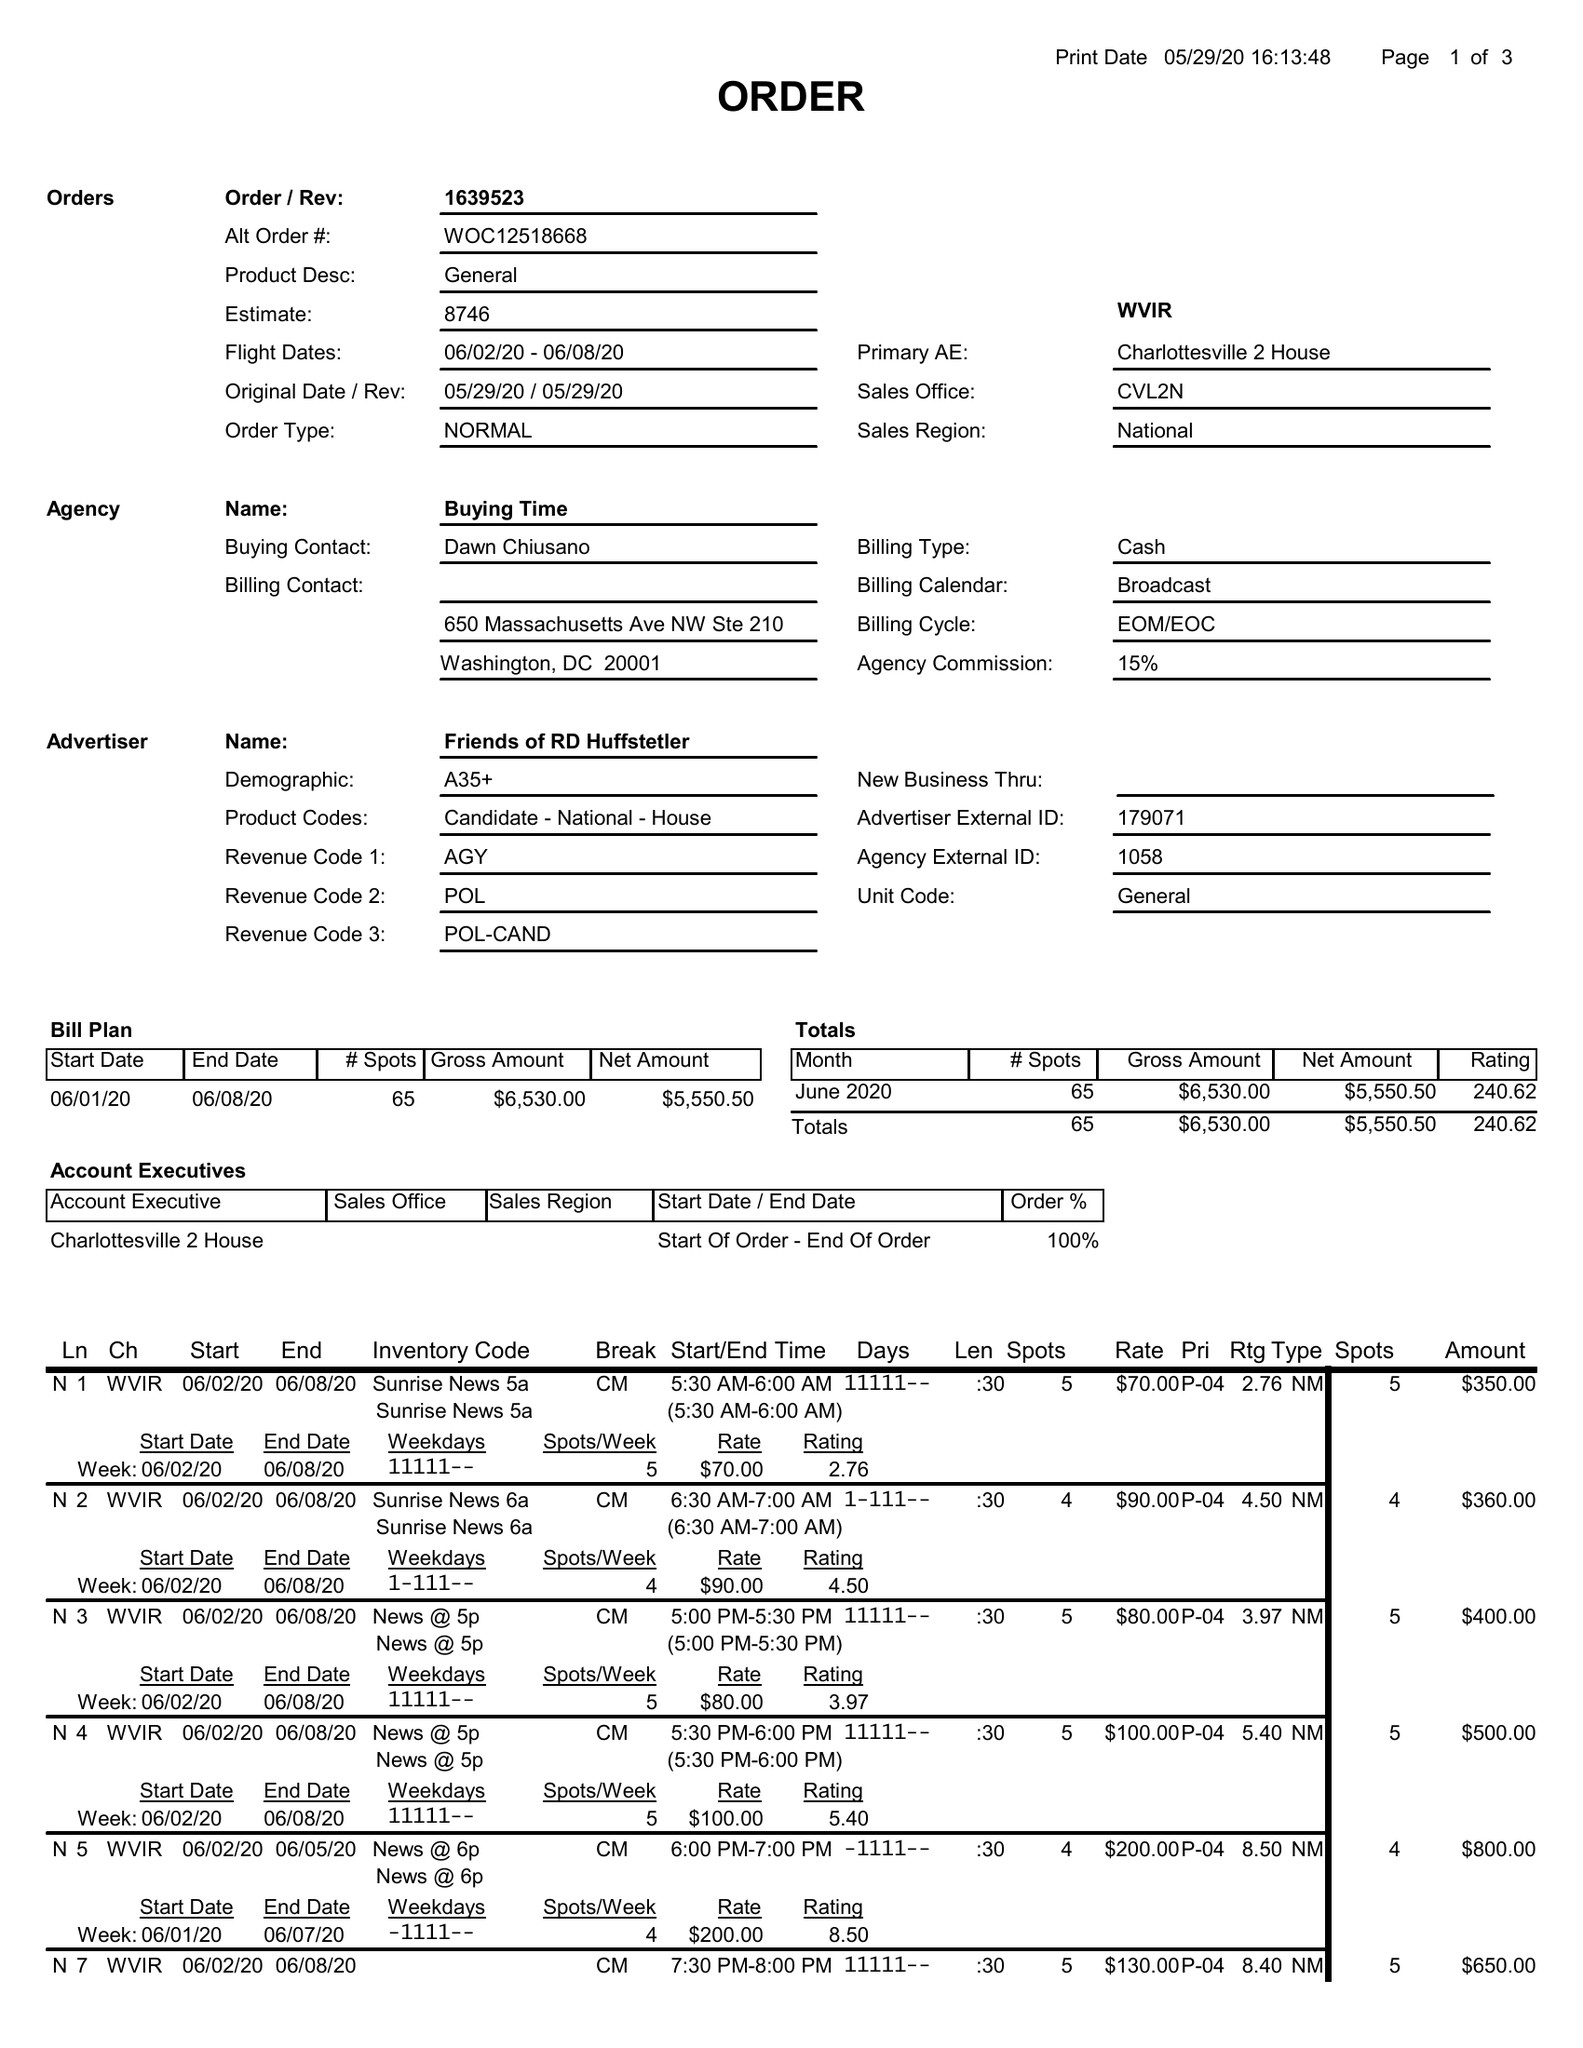What is the value for the flight_to?
Answer the question using a single word or phrase. 06/08/20 